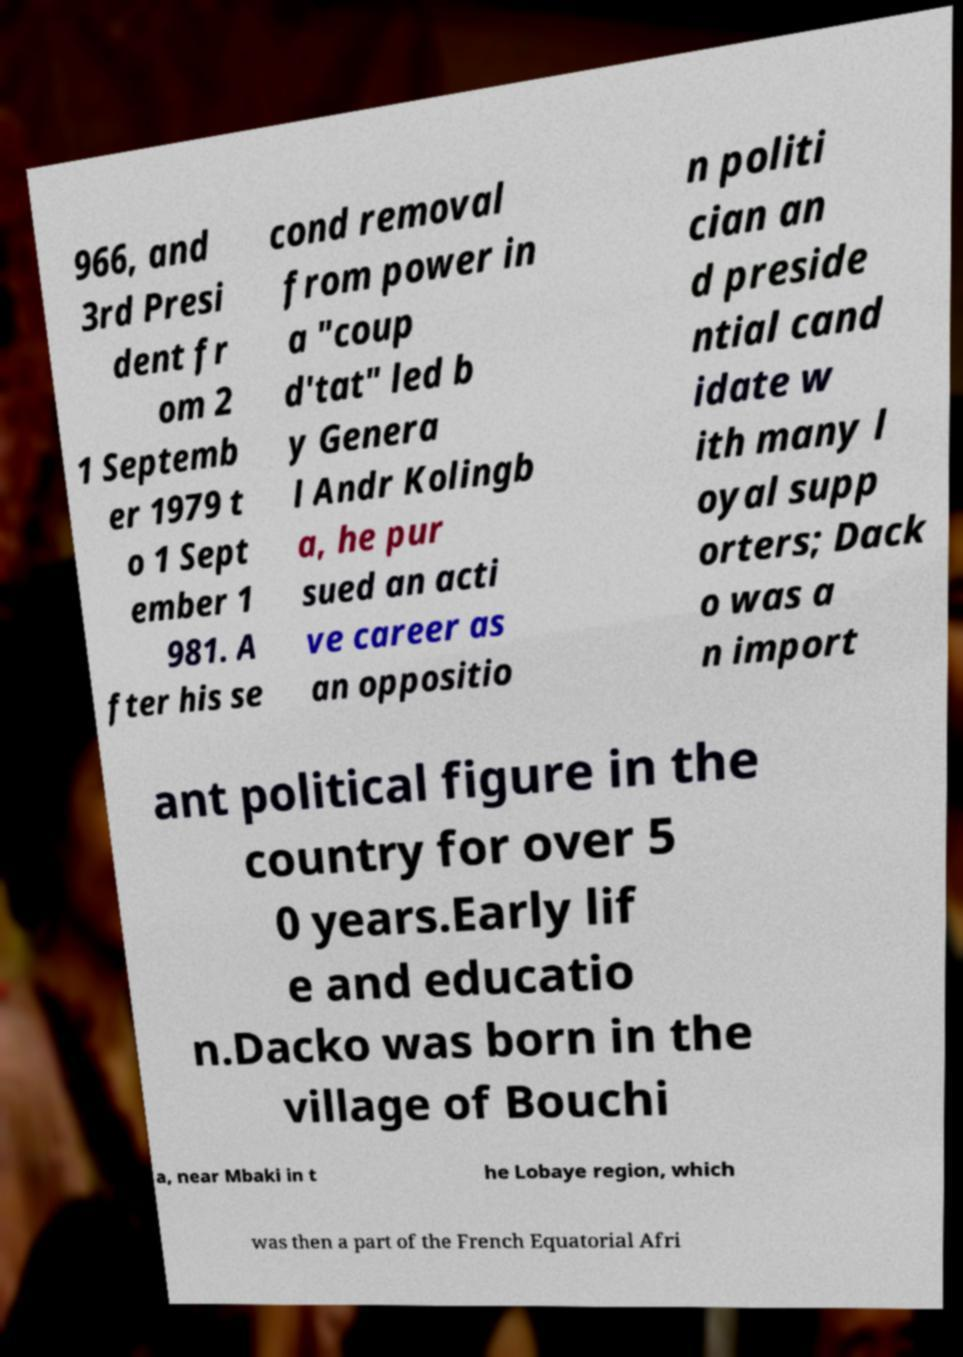There's text embedded in this image that I need extracted. Can you transcribe it verbatim? 966, and 3rd Presi dent fr om 2 1 Septemb er 1979 t o 1 Sept ember 1 981. A fter his se cond removal from power in a "coup d'tat" led b y Genera l Andr Kolingb a, he pur sued an acti ve career as an oppositio n politi cian an d preside ntial cand idate w ith many l oyal supp orters; Dack o was a n import ant political figure in the country for over 5 0 years.Early lif e and educatio n.Dacko was born in the village of Bouchi a, near Mbaki in t he Lobaye region, which was then a part of the French Equatorial Afri 